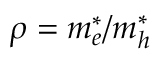Convert formula to latex. <formula><loc_0><loc_0><loc_500><loc_500>\rho = m _ { e } ^ { * } / m _ { h } ^ { * }</formula> 